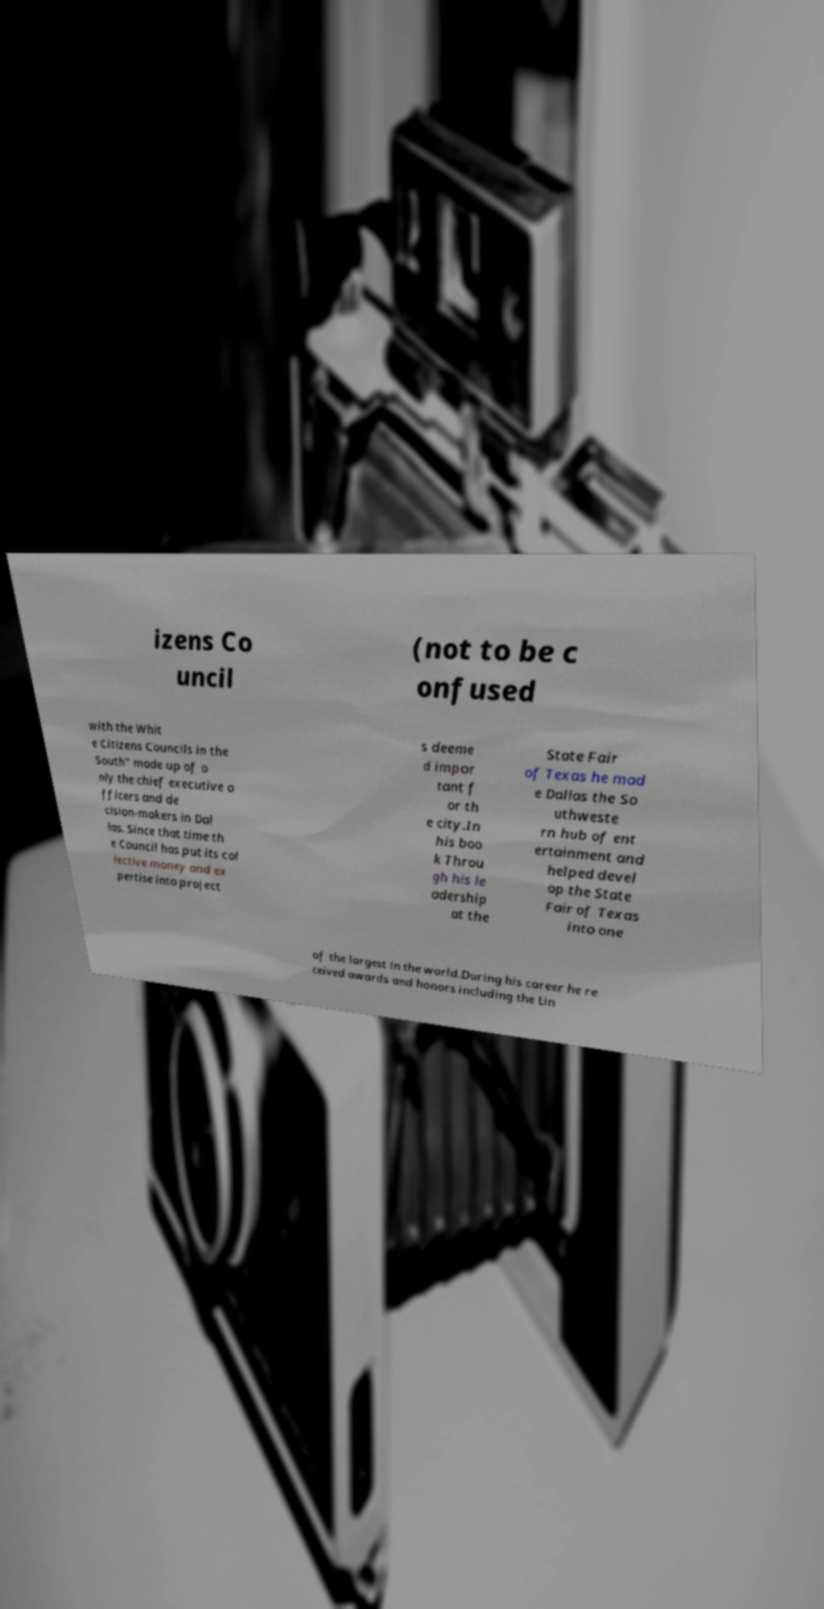There's text embedded in this image that I need extracted. Can you transcribe it verbatim? izens Co uncil (not to be c onfused with the Whit e Citizens Councils in the South" made up of o nly the chief executive o fficers and de cision-makers in Dal las. Since that time th e Council has put its col lective money and ex pertise into project s deeme d impor tant f or th e city.In his boo k Throu gh his le adership at the State Fair of Texas he mad e Dallas the So uthweste rn hub of ent ertainment and helped devel op the State Fair of Texas into one of the largest in the world.During his career he re ceived awards and honors including the Lin 